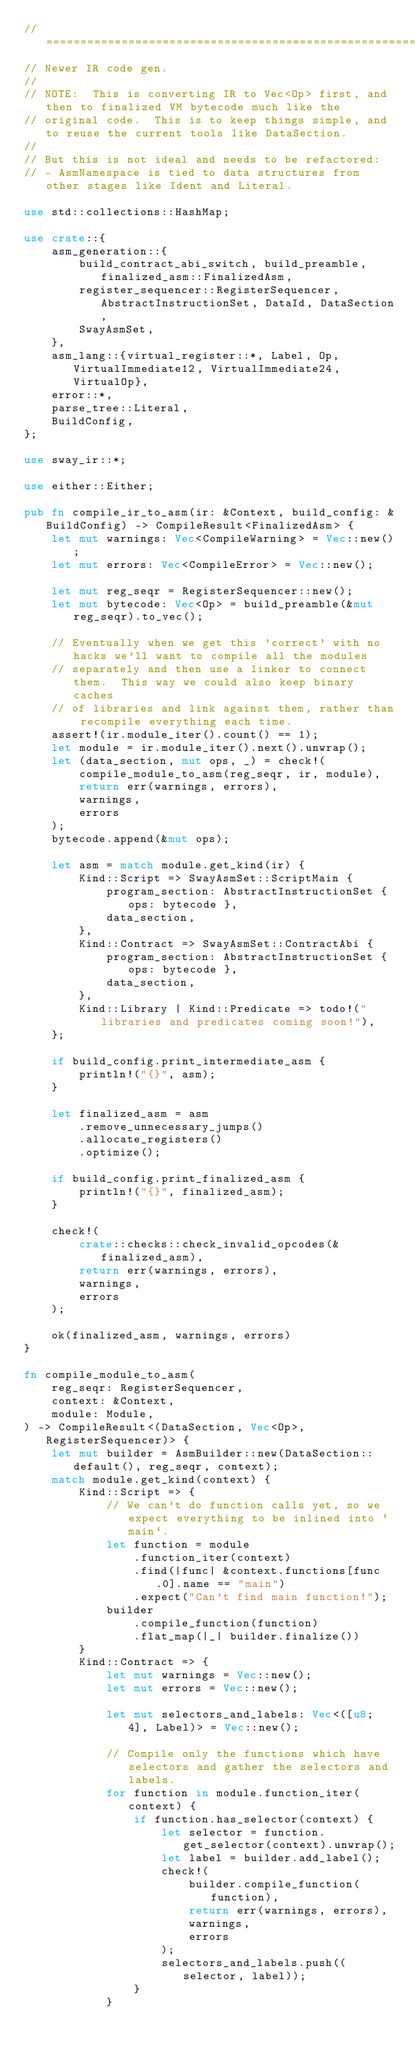Convert code to text. <code><loc_0><loc_0><loc_500><loc_500><_Rust_>// =================================================================================================
// Newer IR code gen.
//
// NOTE:  This is converting IR to Vec<Op> first, and then to finalized VM bytecode much like the
// original code.  This is to keep things simple, and to reuse the current tools like DataSection.
//
// But this is not ideal and needs to be refactored:
// - AsmNamespace is tied to data structures from other stages like Ident and Literal.

use std::collections::HashMap;

use crate::{
    asm_generation::{
        build_contract_abi_switch, build_preamble, finalized_asm::FinalizedAsm,
        register_sequencer::RegisterSequencer, AbstractInstructionSet, DataId, DataSection,
        SwayAsmSet,
    },
    asm_lang::{virtual_register::*, Label, Op, VirtualImmediate12, VirtualImmediate24, VirtualOp},
    error::*,
    parse_tree::Literal,
    BuildConfig,
};

use sway_ir::*;

use either::Either;

pub fn compile_ir_to_asm(ir: &Context, build_config: &BuildConfig) -> CompileResult<FinalizedAsm> {
    let mut warnings: Vec<CompileWarning> = Vec::new();
    let mut errors: Vec<CompileError> = Vec::new();

    let mut reg_seqr = RegisterSequencer::new();
    let mut bytecode: Vec<Op> = build_preamble(&mut reg_seqr).to_vec();

    // Eventually when we get this 'correct' with no hacks we'll want to compile all the modules
    // separately and then use a linker to connect them.  This way we could also keep binary caches
    // of libraries and link against them, rather than recompile everything each time.
    assert!(ir.module_iter().count() == 1);
    let module = ir.module_iter().next().unwrap();
    let (data_section, mut ops, _) = check!(
        compile_module_to_asm(reg_seqr, ir, module),
        return err(warnings, errors),
        warnings,
        errors
    );
    bytecode.append(&mut ops);

    let asm = match module.get_kind(ir) {
        Kind::Script => SwayAsmSet::ScriptMain {
            program_section: AbstractInstructionSet { ops: bytecode },
            data_section,
        },
        Kind::Contract => SwayAsmSet::ContractAbi {
            program_section: AbstractInstructionSet { ops: bytecode },
            data_section,
        },
        Kind::Library | Kind::Predicate => todo!("libraries and predicates coming soon!"),
    };

    if build_config.print_intermediate_asm {
        println!("{}", asm);
    }

    let finalized_asm = asm
        .remove_unnecessary_jumps()
        .allocate_registers()
        .optimize();

    if build_config.print_finalized_asm {
        println!("{}", finalized_asm);
    }

    check!(
        crate::checks::check_invalid_opcodes(&finalized_asm),
        return err(warnings, errors),
        warnings,
        errors
    );

    ok(finalized_asm, warnings, errors)
}

fn compile_module_to_asm(
    reg_seqr: RegisterSequencer,
    context: &Context,
    module: Module,
) -> CompileResult<(DataSection, Vec<Op>, RegisterSequencer)> {
    let mut builder = AsmBuilder::new(DataSection::default(), reg_seqr, context);
    match module.get_kind(context) {
        Kind::Script => {
            // We can't do function calls yet, so we expect everything to be inlined into `main`.
            let function = module
                .function_iter(context)
                .find(|func| &context.functions[func.0].name == "main")
                .expect("Can't find main function!");
            builder
                .compile_function(function)
                .flat_map(|_| builder.finalize())
        }
        Kind::Contract => {
            let mut warnings = Vec::new();
            let mut errors = Vec::new();

            let mut selectors_and_labels: Vec<([u8; 4], Label)> = Vec::new();

            // Compile only the functions which have selectors and gather the selectors and labels.
            for function in module.function_iter(context) {
                if function.has_selector(context) {
                    let selector = function.get_selector(context).unwrap();
                    let label = builder.add_label();
                    check!(
                        builder.compile_function(function),
                        return err(warnings, errors),
                        warnings,
                        errors
                    );
                    selectors_and_labels.push((selector, label));
                }
            }</code> 